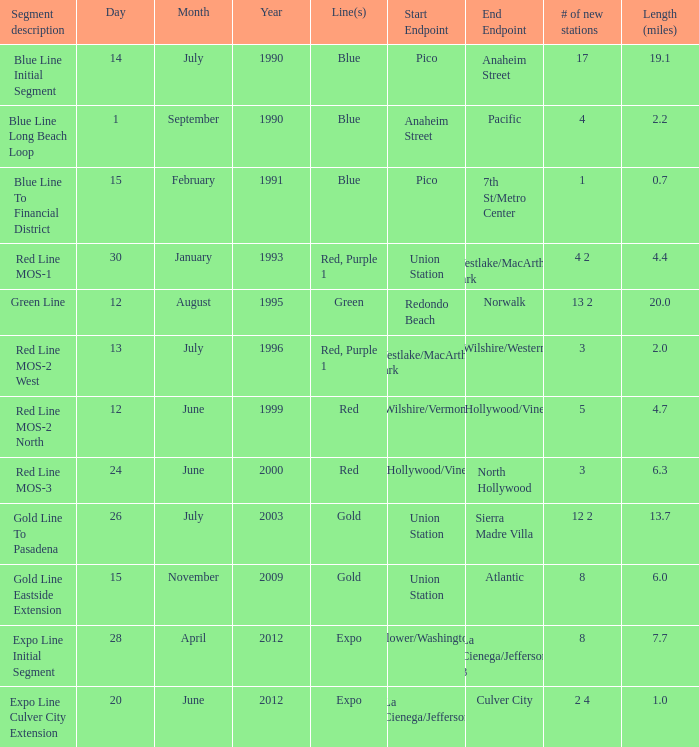What is the distance in miles between westlake/macarthur park and wilshire/western endpoints? 2.0. 